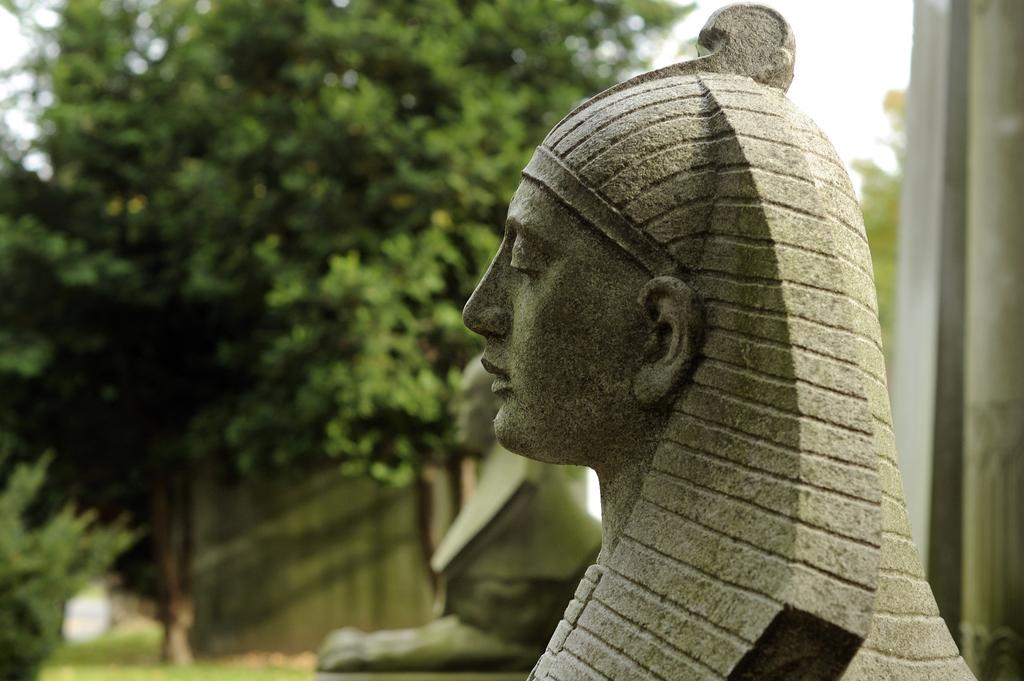How many sculptures can be seen in the image? There are two sculptures in the image. In which direction are the sculptures facing? The sculptures are facing towards the left side. What can be seen in the background of the image? There are trees in the background of the image. What is visible at the top of the image? The sky is visible at the top of the image. What type of line is being used to measure the distance between the sculptures in the image? There is no line present in the image to measure the distance between the sculptures. 